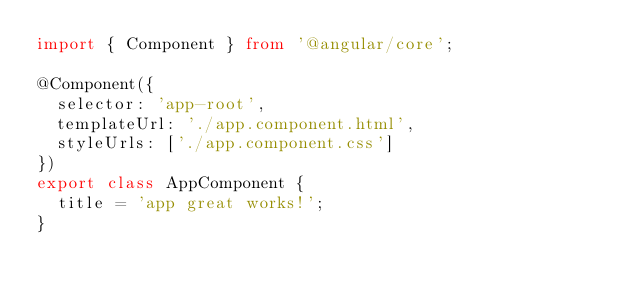<code> <loc_0><loc_0><loc_500><loc_500><_TypeScript_>import { Component } from '@angular/core';

@Component({
  selector: 'app-root',
  templateUrl: './app.component.html',
  styleUrls: ['./app.component.css']
})
export class AppComponent {
  title = 'app great works!';
}
</code> 